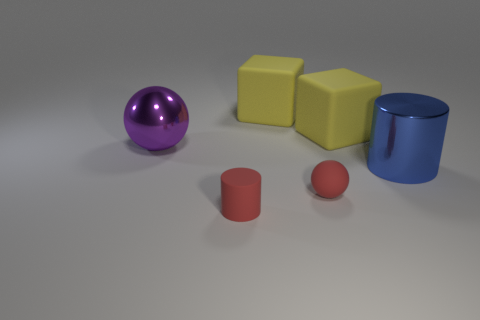What could the arrangement of these objects represent? The arrangement could symbolize a variety of concepts. It might represent diversity through the different shapes and colors or indicate a playful setting, similar to children's toys. Alternatively, it might simply be an exercise in geometry and color theory for artistic or educational purposes. 